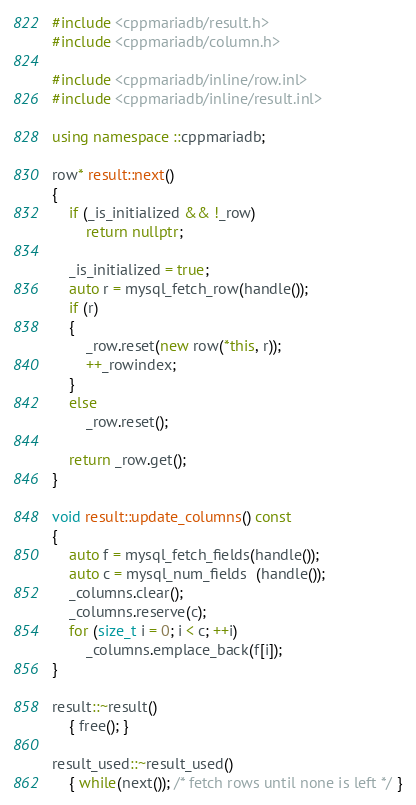Convert code to text. <code><loc_0><loc_0><loc_500><loc_500><_C++_>#include <cppmariadb/result.h>
#include <cppmariadb/column.h>

#include <cppmariadb/inline/row.inl>
#include <cppmariadb/inline/result.inl>

using namespace ::cppmariadb;

row* result::next()
{
    if (_is_initialized && !_row)
        return nullptr;

    _is_initialized = true;
    auto r = mysql_fetch_row(handle());
    if (r)
    {
        _row.reset(new row(*this, r));
        ++_rowindex;
    }
    else
        _row.reset();

    return _row.get();
}

void result::update_columns() const
{
    auto f = mysql_fetch_fields(handle());
    auto c = mysql_num_fields  (handle());
    _columns.clear();
    _columns.reserve(c);
    for (size_t i = 0; i < c; ++i)
        _columns.emplace_back(f[i]);
}

result::~result()
    { free(); }

result_used::~result_used()
    { while(next()); /* fetch rows until none is left */ }</code> 